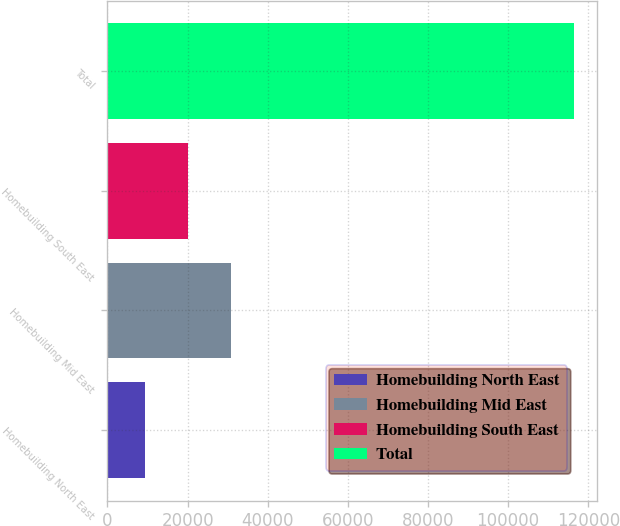<chart> <loc_0><loc_0><loc_500><loc_500><bar_chart><fcel>Homebuilding North East<fcel>Homebuilding Mid East<fcel>Homebuilding South East<fcel>Total<nl><fcel>9461<fcel>30860.2<fcel>20160.6<fcel>116457<nl></chart> 